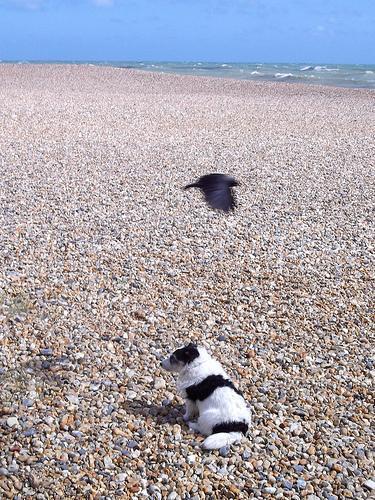How many birds?
Give a very brief answer. 1. 